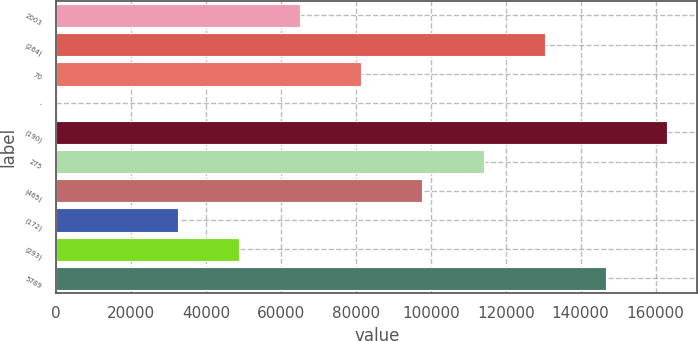<chart> <loc_0><loc_0><loc_500><loc_500><bar_chart><fcel>2003<fcel>(264)<fcel>70<fcel>-<fcel>(190)<fcel>275<fcel>(465)<fcel>(172)<fcel>(293)<fcel>5789<nl><fcel>65193.2<fcel>130384<fcel>81491<fcel>2<fcel>162980<fcel>114087<fcel>97788.8<fcel>32597.6<fcel>48895.4<fcel>146682<nl></chart> 